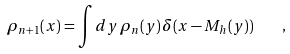Convert formula to latex. <formula><loc_0><loc_0><loc_500><loc_500>\rho _ { n + 1 } ( x ) = \int d y \, \rho _ { n } ( y ) \, \delta ( x - M _ { h } ( y ) ) \quad ,</formula> 